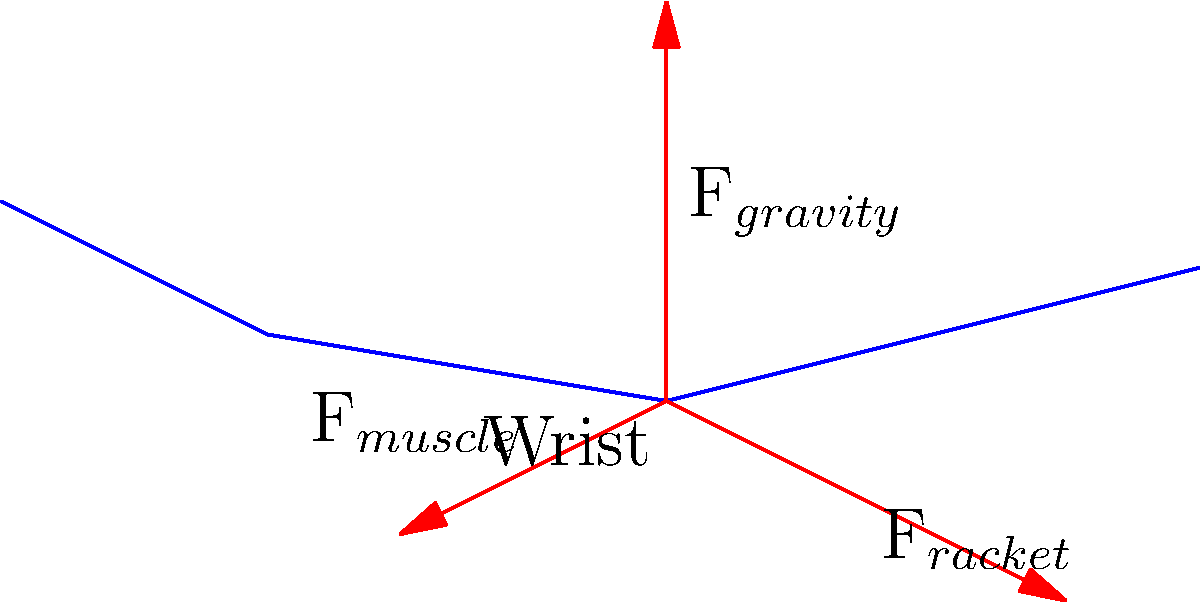In the force diagram of a tennis player's serve motion, which force is likely to have the greatest magnitude during the moment of impact with the ball, and how does this relate to Chloé Paquet's powerful serve technique? To analyze the force diagram for a player's serve motion, let's break it down step-by-step:

1. Identify the forces:
   - $F_{gravity}$: Downward force due to the weight of the arm and racket
   - $F_{muscle}$: Force exerted by the player's muscles
   - $F_{racket}$: Reaction force from the racket during impact

2. Consider the moment of impact:
   - The serve is a powerful, explosive motion
   - The player aims to transfer maximum energy to the ball

3. Analyze each force:
   - $F_{gravity}$ remains constant and is relatively small compared to the other forces
   - $F_{muscle}$ is large during the swing but may decrease slightly at impact
   - $F_{racket}$ spikes dramatically at the moment of impact

4. Apply Newton's Third Law:
   - The force exerted on the ball is equal and opposite to $F_{racket}$
   - To achieve a powerful serve, $F_{racket}$ must be maximized

5. Relate to Chloé Paquet's technique:
   - Known for her powerful serve
   - Likely optimizes her technique to maximize $F_{racket}$ at impact

Given these considerations, $F_{racket}$ is likely to have the greatest magnitude during the moment of impact. This aligns with Chloé Paquet's powerful serve technique, as she would focus on maximizing this force to achieve high serve speeds.
Answer: $F_{racket}$ (reaction force from the racket) 